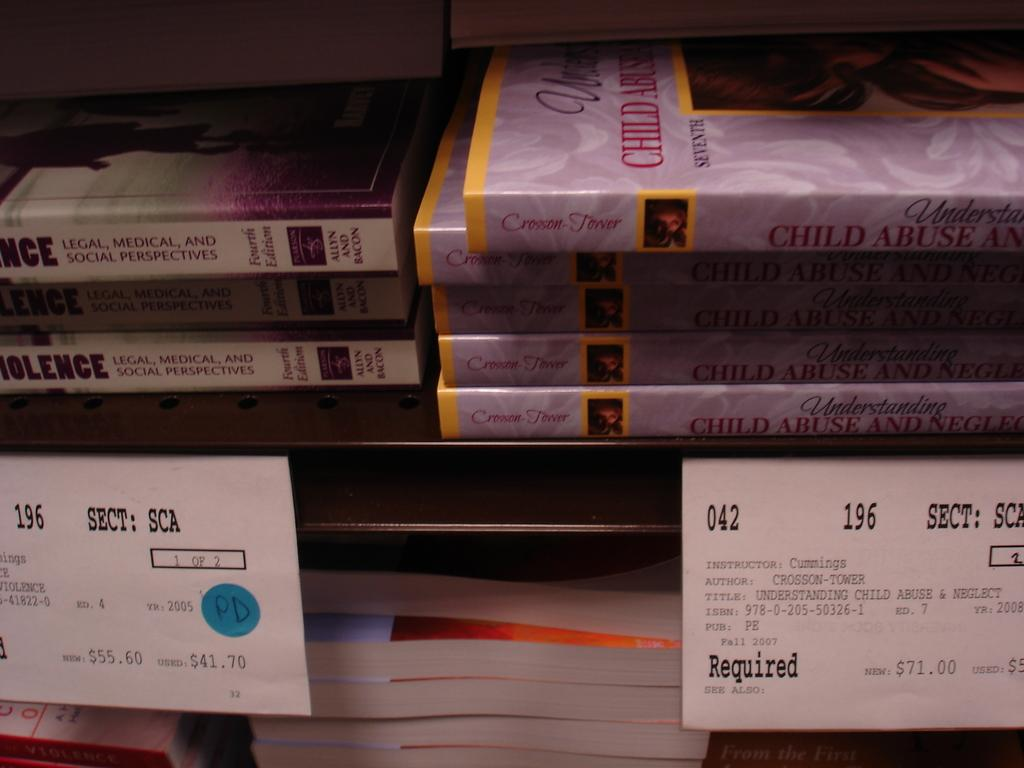<image>
Relay a brief, clear account of the picture shown. A shelve at a school bookstore depicting the price, section, author, and class Instructor name for each book. 